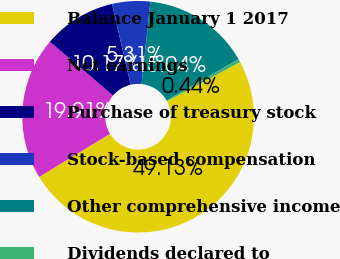Convert chart. <chart><loc_0><loc_0><loc_500><loc_500><pie_chart><fcel>Balance January 1 2017<fcel>Net earnings<fcel>Purchase of treasury stock<fcel>Stock-based compensation<fcel>Other comprehensive income<fcel>Dividends declared to<nl><fcel>49.13%<fcel>19.91%<fcel>10.17%<fcel>5.31%<fcel>15.04%<fcel>0.44%<nl></chart> 